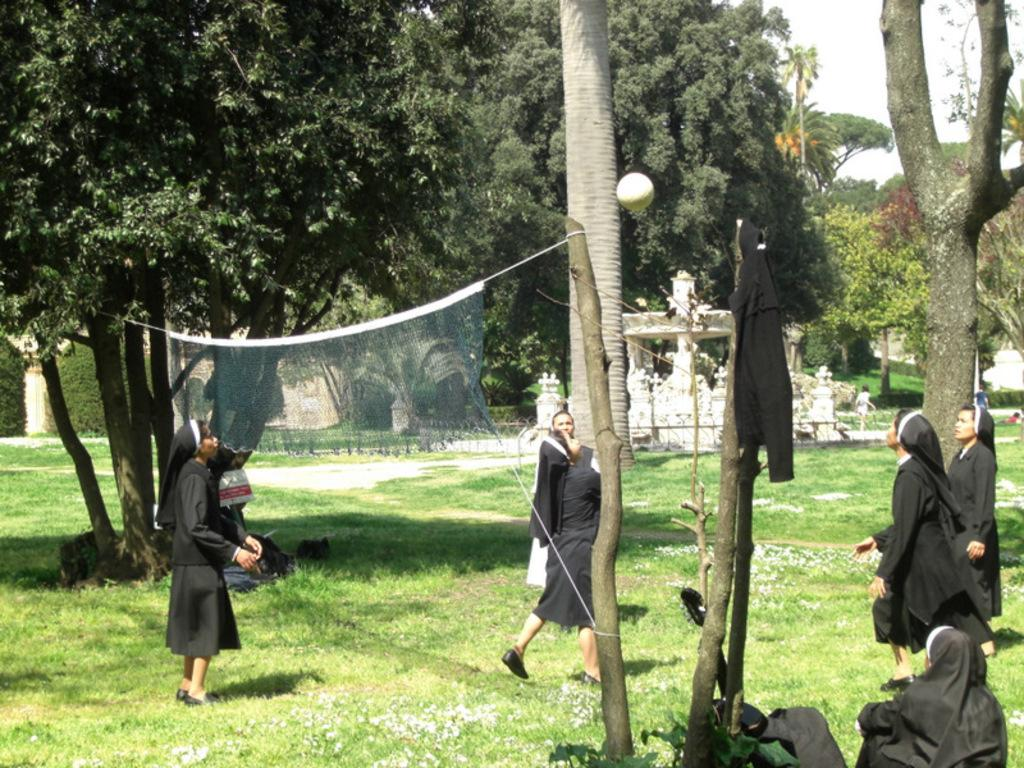What activity are the girls engaged in within the image? The girls are playing volleyball in the image. What type of natural environment is visible in the image? There are trees visible in the image, suggesting a natural setting. What surface are the girls playing on? There is grass at the bottom of the image, indicating that they are playing on a grassy area. What is used to separate the two teams in the game? There is a net in the image, which is used to separate the teams during a volleyball game. What kitchen appliance can be seen on the court during the game? There are no kitchen appliances present in the image; it features girls playing volleyball on a grassy area with trees in the background. 